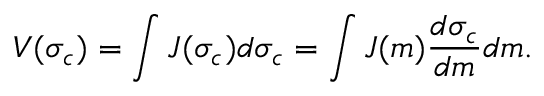<formula> <loc_0><loc_0><loc_500><loc_500>V ( \sigma _ { c } ) = \int J ( \sigma _ { c } ) d \sigma _ { c } = \int J ( m ) \frac { d \sigma _ { c } } { d m } d m .</formula> 